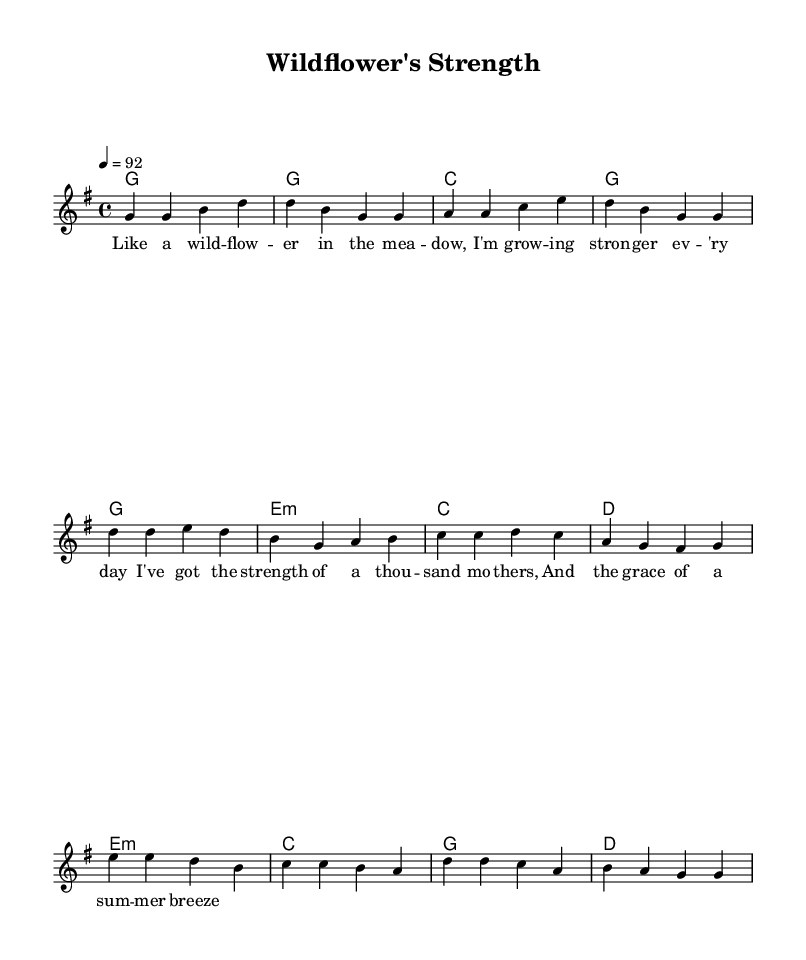What is the key signature of this music? The key signature is G major, which has one sharp: F sharp. This can be determined by the initial indication of the key at the beginning of the score.
Answer: G major What is the time signature of this piece? The time signature is four-four, as indicated at the beginning of the score. This means there are four beats in each measure, and the quarter note receives one beat.
Answer: Four-four What is the tempo marking for this piece? The tempo marking is 92 beats per minute, indicated by the "4 = 92" at the beginning of the global settings. This specifies the pace at which the piece should be played.
Answer: 92 How many measures are in the verse? The verse consists of four measures, which can be counted by looking at the bars in the melody section provided in the score. Each grouping of notes between two vertical lines indicates a measure.
Answer: Four What is the main theme conveyed in the lyrics of the chorus? The chorus conveys a theme of strength and grace, as suggested by phrases like "the strength of a thousand mothers" and "the grace of a summer breeze," which highlight aspects of femininity and empowerment.
Answer: Strength and grace Which chord is played during the first measure of the chorus? The chord played during the first measure of the chorus is a G major chord, as shown in the harmonies section right before the melody starts the chorus. This is the initial harmonic support for this part of the song.
Answer: G major 